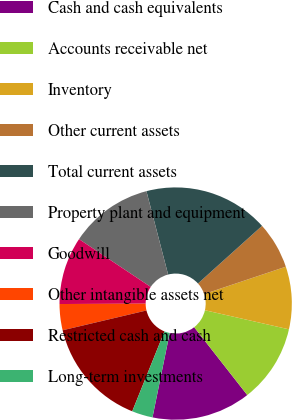Convert chart to OTSL. <chart><loc_0><loc_0><loc_500><loc_500><pie_chart><fcel>Cash and cash equivalents<fcel>Accounts receivable net<fcel>Inventory<fcel>Other current assets<fcel>Total current assets<fcel>Property plant and equipment<fcel>Goodwill<fcel>Other intangible assets net<fcel>Restricted cash and cash<fcel>Long-term investments<nl><fcel>13.77%<fcel>10.87%<fcel>8.7%<fcel>6.52%<fcel>17.39%<fcel>11.59%<fcel>9.42%<fcel>3.63%<fcel>15.21%<fcel>2.9%<nl></chart> 